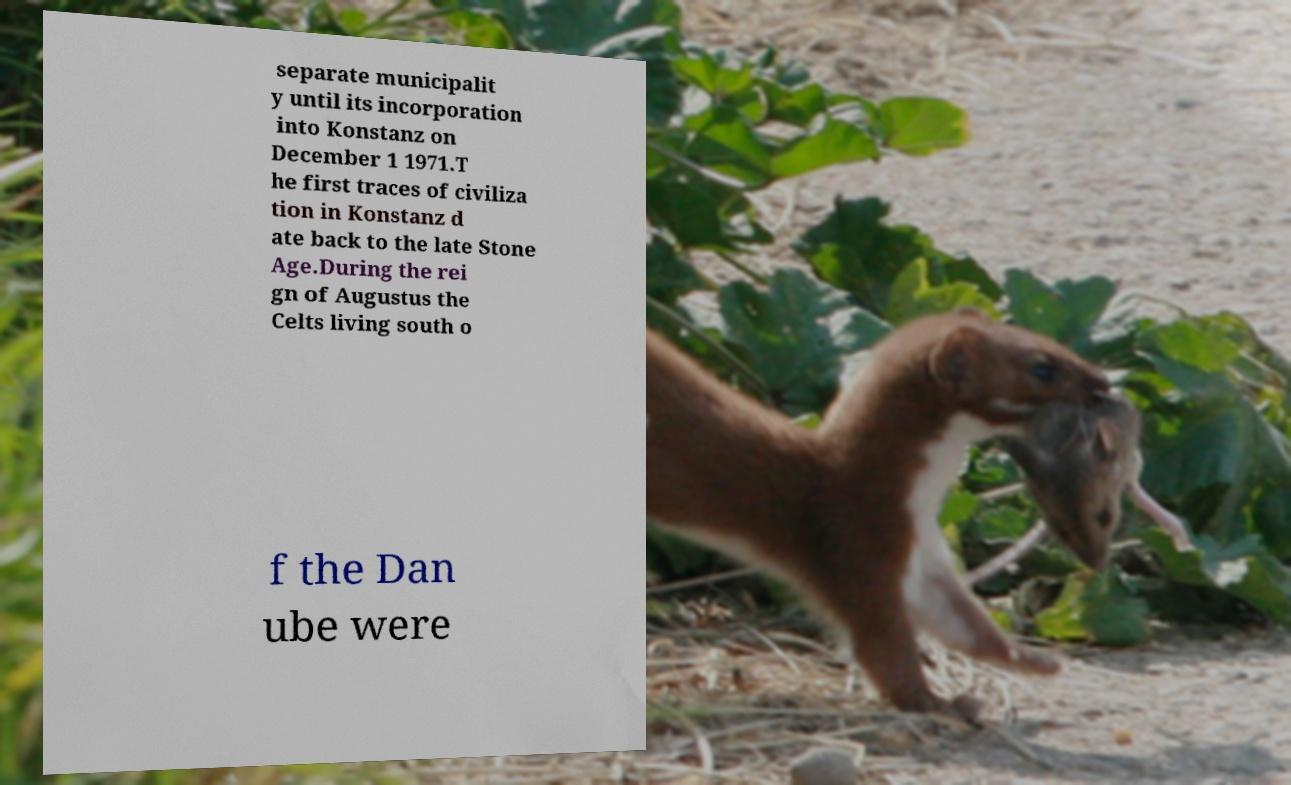There's text embedded in this image that I need extracted. Can you transcribe it verbatim? separate municipalit y until its incorporation into Konstanz on December 1 1971.T he first traces of civiliza tion in Konstanz d ate back to the late Stone Age.During the rei gn of Augustus the Celts living south o f the Dan ube were 